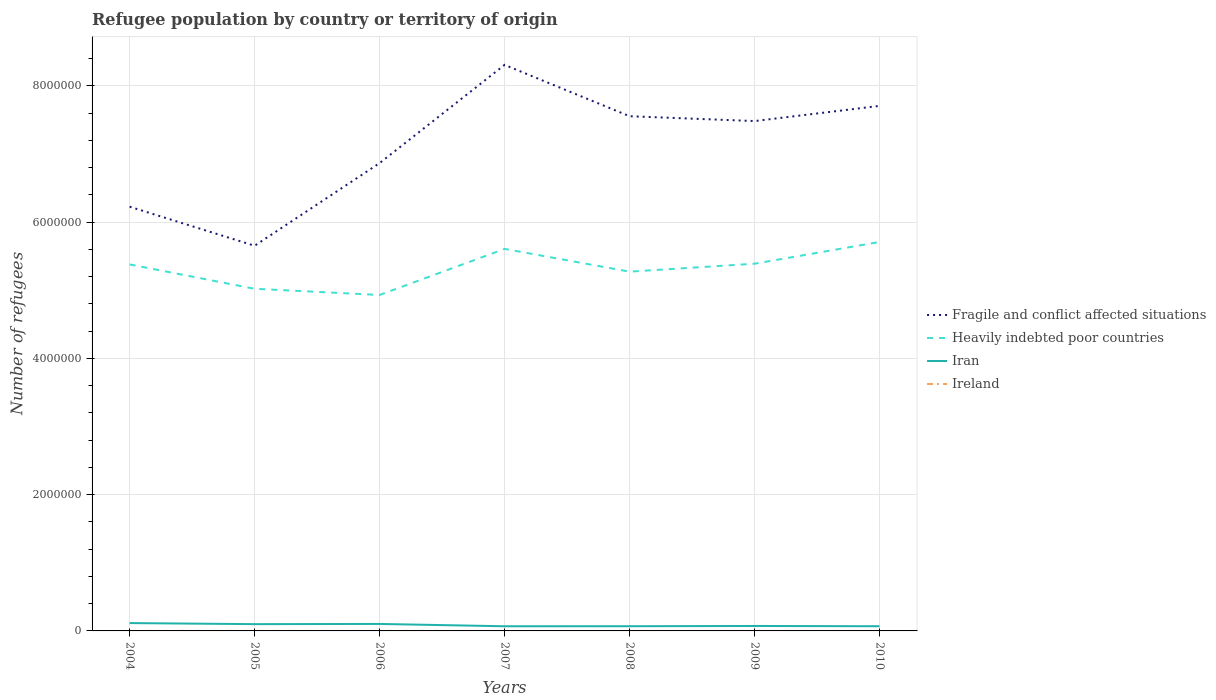Is the number of lines equal to the number of legend labels?
Make the answer very short. Yes. Across all years, what is the maximum number of refugees in Fragile and conflict affected situations?
Keep it short and to the point. 5.65e+06. What is the total number of refugees in Ireland in the graph?
Offer a very short reply. -1. What is the difference between the highest and the second highest number of refugees in Iran?
Your response must be concise. 4.68e+04. Is the number of refugees in Fragile and conflict affected situations strictly greater than the number of refugees in Heavily indebted poor countries over the years?
Provide a succinct answer. No. How many lines are there?
Ensure brevity in your answer.  4. How many years are there in the graph?
Give a very brief answer. 7. Does the graph contain grids?
Your answer should be compact. Yes. Where does the legend appear in the graph?
Provide a succinct answer. Center right. How are the legend labels stacked?
Your answer should be very brief. Vertical. What is the title of the graph?
Make the answer very short. Refugee population by country or territory of origin. What is the label or title of the Y-axis?
Offer a terse response. Number of refugees. What is the Number of refugees of Fragile and conflict affected situations in 2004?
Your answer should be very brief. 6.23e+06. What is the Number of refugees in Heavily indebted poor countries in 2004?
Provide a succinct answer. 5.38e+06. What is the Number of refugees of Iran in 2004?
Offer a terse response. 1.15e+05. What is the Number of refugees in Ireland in 2004?
Offer a terse response. 3. What is the Number of refugees in Fragile and conflict affected situations in 2005?
Make the answer very short. 5.65e+06. What is the Number of refugees of Heavily indebted poor countries in 2005?
Keep it short and to the point. 5.02e+06. What is the Number of refugees in Iran in 2005?
Provide a short and direct response. 9.94e+04. What is the Number of refugees of Ireland in 2005?
Provide a short and direct response. 21. What is the Number of refugees in Fragile and conflict affected situations in 2006?
Ensure brevity in your answer.  6.87e+06. What is the Number of refugees of Heavily indebted poor countries in 2006?
Offer a terse response. 4.93e+06. What is the Number of refugees in Iran in 2006?
Provide a short and direct response. 1.02e+05. What is the Number of refugees of Fragile and conflict affected situations in 2007?
Make the answer very short. 8.31e+06. What is the Number of refugees in Heavily indebted poor countries in 2007?
Offer a terse response. 5.61e+06. What is the Number of refugees in Iran in 2007?
Give a very brief answer. 6.84e+04. What is the Number of refugees in Fragile and conflict affected situations in 2008?
Offer a very short reply. 7.56e+06. What is the Number of refugees in Heavily indebted poor countries in 2008?
Your answer should be very brief. 5.27e+06. What is the Number of refugees in Iran in 2008?
Offer a terse response. 6.91e+04. What is the Number of refugees of Ireland in 2008?
Your answer should be compact. 7. What is the Number of refugees of Fragile and conflict affected situations in 2009?
Your answer should be very brief. 7.48e+06. What is the Number of refugees of Heavily indebted poor countries in 2009?
Provide a succinct answer. 5.39e+06. What is the Number of refugees of Iran in 2009?
Your response must be concise. 7.28e+04. What is the Number of refugees in Ireland in 2009?
Give a very brief answer. 7. What is the Number of refugees of Fragile and conflict affected situations in 2010?
Your answer should be very brief. 7.71e+06. What is the Number of refugees in Heavily indebted poor countries in 2010?
Your answer should be very brief. 5.71e+06. What is the Number of refugees of Iran in 2010?
Offer a terse response. 6.88e+04. What is the Number of refugees in Ireland in 2010?
Offer a terse response. 8. Across all years, what is the maximum Number of refugees in Fragile and conflict affected situations?
Your answer should be compact. 8.31e+06. Across all years, what is the maximum Number of refugees of Heavily indebted poor countries?
Offer a terse response. 5.71e+06. Across all years, what is the maximum Number of refugees of Iran?
Offer a very short reply. 1.15e+05. Across all years, what is the maximum Number of refugees of Ireland?
Provide a short and direct response. 21. Across all years, what is the minimum Number of refugees of Fragile and conflict affected situations?
Provide a short and direct response. 5.65e+06. Across all years, what is the minimum Number of refugees in Heavily indebted poor countries?
Your answer should be compact. 4.93e+06. Across all years, what is the minimum Number of refugees of Iran?
Keep it short and to the point. 6.84e+04. What is the total Number of refugees of Fragile and conflict affected situations in the graph?
Give a very brief answer. 4.98e+07. What is the total Number of refugees in Heavily indebted poor countries in the graph?
Provide a short and direct response. 3.73e+07. What is the total Number of refugees in Iran in the graph?
Ensure brevity in your answer.  5.96e+05. What is the difference between the Number of refugees of Fragile and conflict affected situations in 2004 and that in 2005?
Ensure brevity in your answer.  5.73e+05. What is the difference between the Number of refugees of Heavily indebted poor countries in 2004 and that in 2005?
Your answer should be very brief. 3.57e+05. What is the difference between the Number of refugees of Iran in 2004 and that in 2005?
Your answer should be very brief. 1.57e+04. What is the difference between the Number of refugees in Fragile and conflict affected situations in 2004 and that in 2006?
Give a very brief answer. -6.40e+05. What is the difference between the Number of refugees in Heavily indebted poor countries in 2004 and that in 2006?
Keep it short and to the point. 4.48e+05. What is the difference between the Number of refugees in Iran in 2004 and that in 2006?
Give a very brief answer. 1.27e+04. What is the difference between the Number of refugees in Fragile and conflict affected situations in 2004 and that in 2007?
Give a very brief answer. -2.08e+06. What is the difference between the Number of refugees in Heavily indebted poor countries in 2004 and that in 2007?
Make the answer very short. -2.28e+05. What is the difference between the Number of refugees in Iran in 2004 and that in 2007?
Your answer should be compact. 4.68e+04. What is the difference between the Number of refugees of Fragile and conflict affected situations in 2004 and that in 2008?
Your answer should be very brief. -1.33e+06. What is the difference between the Number of refugees in Heavily indebted poor countries in 2004 and that in 2008?
Keep it short and to the point. 1.06e+05. What is the difference between the Number of refugees in Iran in 2004 and that in 2008?
Your answer should be compact. 4.61e+04. What is the difference between the Number of refugees of Ireland in 2004 and that in 2008?
Offer a terse response. -4. What is the difference between the Number of refugees of Fragile and conflict affected situations in 2004 and that in 2009?
Keep it short and to the point. -1.26e+06. What is the difference between the Number of refugees of Heavily indebted poor countries in 2004 and that in 2009?
Provide a short and direct response. -1.07e+04. What is the difference between the Number of refugees of Iran in 2004 and that in 2009?
Your answer should be very brief. 4.24e+04. What is the difference between the Number of refugees in Fragile and conflict affected situations in 2004 and that in 2010?
Offer a very short reply. -1.48e+06. What is the difference between the Number of refugees of Heavily indebted poor countries in 2004 and that in 2010?
Your answer should be compact. -3.30e+05. What is the difference between the Number of refugees in Iran in 2004 and that in 2010?
Your answer should be very brief. 4.64e+04. What is the difference between the Number of refugees of Ireland in 2004 and that in 2010?
Offer a very short reply. -5. What is the difference between the Number of refugees of Fragile and conflict affected situations in 2005 and that in 2006?
Offer a very short reply. -1.21e+06. What is the difference between the Number of refugees of Heavily indebted poor countries in 2005 and that in 2006?
Your response must be concise. 9.11e+04. What is the difference between the Number of refugees in Iran in 2005 and that in 2006?
Make the answer very short. -3055. What is the difference between the Number of refugees of Fragile and conflict affected situations in 2005 and that in 2007?
Give a very brief answer. -2.66e+06. What is the difference between the Number of refugees of Heavily indebted poor countries in 2005 and that in 2007?
Your answer should be very brief. -5.85e+05. What is the difference between the Number of refugees of Iran in 2005 and that in 2007?
Offer a very short reply. 3.10e+04. What is the difference between the Number of refugees of Fragile and conflict affected situations in 2005 and that in 2008?
Offer a terse response. -1.90e+06. What is the difference between the Number of refugees of Heavily indebted poor countries in 2005 and that in 2008?
Keep it short and to the point. -2.51e+05. What is the difference between the Number of refugees in Iran in 2005 and that in 2008?
Offer a very short reply. 3.04e+04. What is the difference between the Number of refugees of Fragile and conflict affected situations in 2005 and that in 2009?
Your answer should be compact. -1.83e+06. What is the difference between the Number of refugees of Heavily indebted poor countries in 2005 and that in 2009?
Give a very brief answer. -3.68e+05. What is the difference between the Number of refugees in Iran in 2005 and that in 2009?
Give a very brief answer. 2.67e+04. What is the difference between the Number of refugees of Ireland in 2005 and that in 2009?
Your answer should be very brief. 14. What is the difference between the Number of refugees in Fragile and conflict affected situations in 2005 and that in 2010?
Your answer should be compact. -2.05e+06. What is the difference between the Number of refugees in Heavily indebted poor countries in 2005 and that in 2010?
Ensure brevity in your answer.  -6.87e+05. What is the difference between the Number of refugees in Iran in 2005 and that in 2010?
Keep it short and to the point. 3.06e+04. What is the difference between the Number of refugees of Fragile and conflict affected situations in 2006 and that in 2007?
Make the answer very short. -1.44e+06. What is the difference between the Number of refugees of Heavily indebted poor countries in 2006 and that in 2007?
Provide a short and direct response. -6.76e+05. What is the difference between the Number of refugees of Iran in 2006 and that in 2007?
Offer a very short reply. 3.41e+04. What is the difference between the Number of refugees in Fragile and conflict affected situations in 2006 and that in 2008?
Offer a terse response. -6.88e+05. What is the difference between the Number of refugees in Heavily indebted poor countries in 2006 and that in 2008?
Provide a short and direct response. -3.42e+05. What is the difference between the Number of refugees of Iran in 2006 and that in 2008?
Your response must be concise. 3.34e+04. What is the difference between the Number of refugees of Ireland in 2006 and that in 2008?
Your answer should be compact. -3. What is the difference between the Number of refugees of Fragile and conflict affected situations in 2006 and that in 2009?
Ensure brevity in your answer.  -6.17e+05. What is the difference between the Number of refugees in Heavily indebted poor countries in 2006 and that in 2009?
Provide a short and direct response. -4.59e+05. What is the difference between the Number of refugees in Iran in 2006 and that in 2009?
Offer a very short reply. 2.97e+04. What is the difference between the Number of refugees in Fragile and conflict affected situations in 2006 and that in 2010?
Your answer should be very brief. -8.40e+05. What is the difference between the Number of refugees of Heavily indebted poor countries in 2006 and that in 2010?
Keep it short and to the point. -7.78e+05. What is the difference between the Number of refugees of Iran in 2006 and that in 2010?
Make the answer very short. 3.37e+04. What is the difference between the Number of refugees of Fragile and conflict affected situations in 2007 and that in 2008?
Offer a very short reply. 7.54e+05. What is the difference between the Number of refugees of Heavily indebted poor countries in 2007 and that in 2008?
Give a very brief answer. 3.34e+05. What is the difference between the Number of refugees in Iran in 2007 and that in 2008?
Give a very brief answer. -664. What is the difference between the Number of refugees of Ireland in 2007 and that in 2008?
Ensure brevity in your answer.  3. What is the difference between the Number of refugees of Fragile and conflict affected situations in 2007 and that in 2009?
Your answer should be very brief. 8.25e+05. What is the difference between the Number of refugees of Heavily indebted poor countries in 2007 and that in 2009?
Offer a very short reply. 2.17e+05. What is the difference between the Number of refugees in Iran in 2007 and that in 2009?
Provide a succinct answer. -4377. What is the difference between the Number of refugees of Ireland in 2007 and that in 2009?
Your response must be concise. 3. What is the difference between the Number of refugees in Fragile and conflict affected situations in 2007 and that in 2010?
Provide a short and direct response. 6.02e+05. What is the difference between the Number of refugees of Heavily indebted poor countries in 2007 and that in 2010?
Provide a succinct answer. -1.02e+05. What is the difference between the Number of refugees in Iran in 2007 and that in 2010?
Your response must be concise. -394. What is the difference between the Number of refugees of Ireland in 2007 and that in 2010?
Provide a succinct answer. 2. What is the difference between the Number of refugees of Fragile and conflict affected situations in 2008 and that in 2009?
Offer a very short reply. 7.10e+04. What is the difference between the Number of refugees in Heavily indebted poor countries in 2008 and that in 2009?
Your answer should be compact. -1.17e+05. What is the difference between the Number of refugees of Iran in 2008 and that in 2009?
Your answer should be compact. -3713. What is the difference between the Number of refugees in Ireland in 2008 and that in 2009?
Offer a very short reply. 0. What is the difference between the Number of refugees of Fragile and conflict affected situations in 2008 and that in 2010?
Keep it short and to the point. -1.52e+05. What is the difference between the Number of refugees of Heavily indebted poor countries in 2008 and that in 2010?
Keep it short and to the point. -4.36e+05. What is the difference between the Number of refugees of Iran in 2008 and that in 2010?
Offer a terse response. 270. What is the difference between the Number of refugees of Fragile and conflict affected situations in 2009 and that in 2010?
Provide a succinct answer. -2.23e+05. What is the difference between the Number of refugees of Heavily indebted poor countries in 2009 and that in 2010?
Keep it short and to the point. -3.19e+05. What is the difference between the Number of refugees in Iran in 2009 and that in 2010?
Offer a terse response. 3983. What is the difference between the Number of refugees of Ireland in 2009 and that in 2010?
Offer a very short reply. -1. What is the difference between the Number of refugees of Fragile and conflict affected situations in 2004 and the Number of refugees of Heavily indebted poor countries in 2005?
Offer a very short reply. 1.20e+06. What is the difference between the Number of refugees of Fragile and conflict affected situations in 2004 and the Number of refugees of Iran in 2005?
Ensure brevity in your answer.  6.13e+06. What is the difference between the Number of refugees in Fragile and conflict affected situations in 2004 and the Number of refugees in Ireland in 2005?
Keep it short and to the point. 6.23e+06. What is the difference between the Number of refugees in Heavily indebted poor countries in 2004 and the Number of refugees in Iran in 2005?
Your answer should be very brief. 5.28e+06. What is the difference between the Number of refugees in Heavily indebted poor countries in 2004 and the Number of refugees in Ireland in 2005?
Offer a terse response. 5.38e+06. What is the difference between the Number of refugees of Iran in 2004 and the Number of refugees of Ireland in 2005?
Your answer should be very brief. 1.15e+05. What is the difference between the Number of refugees in Fragile and conflict affected situations in 2004 and the Number of refugees in Heavily indebted poor countries in 2006?
Make the answer very short. 1.30e+06. What is the difference between the Number of refugees in Fragile and conflict affected situations in 2004 and the Number of refugees in Iran in 2006?
Offer a very short reply. 6.12e+06. What is the difference between the Number of refugees of Fragile and conflict affected situations in 2004 and the Number of refugees of Ireland in 2006?
Provide a short and direct response. 6.23e+06. What is the difference between the Number of refugees in Heavily indebted poor countries in 2004 and the Number of refugees in Iran in 2006?
Offer a very short reply. 5.28e+06. What is the difference between the Number of refugees in Heavily indebted poor countries in 2004 and the Number of refugees in Ireland in 2006?
Ensure brevity in your answer.  5.38e+06. What is the difference between the Number of refugees of Iran in 2004 and the Number of refugees of Ireland in 2006?
Keep it short and to the point. 1.15e+05. What is the difference between the Number of refugees in Fragile and conflict affected situations in 2004 and the Number of refugees in Heavily indebted poor countries in 2007?
Provide a short and direct response. 6.19e+05. What is the difference between the Number of refugees of Fragile and conflict affected situations in 2004 and the Number of refugees of Iran in 2007?
Make the answer very short. 6.16e+06. What is the difference between the Number of refugees in Fragile and conflict affected situations in 2004 and the Number of refugees in Ireland in 2007?
Provide a short and direct response. 6.23e+06. What is the difference between the Number of refugees in Heavily indebted poor countries in 2004 and the Number of refugees in Iran in 2007?
Provide a short and direct response. 5.31e+06. What is the difference between the Number of refugees of Heavily indebted poor countries in 2004 and the Number of refugees of Ireland in 2007?
Provide a short and direct response. 5.38e+06. What is the difference between the Number of refugees in Iran in 2004 and the Number of refugees in Ireland in 2007?
Make the answer very short. 1.15e+05. What is the difference between the Number of refugees of Fragile and conflict affected situations in 2004 and the Number of refugees of Heavily indebted poor countries in 2008?
Keep it short and to the point. 9.53e+05. What is the difference between the Number of refugees of Fragile and conflict affected situations in 2004 and the Number of refugees of Iran in 2008?
Offer a very short reply. 6.16e+06. What is the difference between the Number of refugees in Fragile and conflict affected situations in 2004 and the Number of refugees in Ireland in 2008?
Keep it short and to the point. 6.23e+06. What is the difference between the Number of refugees in Heavily indebted poor countries in 2004 and the Number of refugees in Iran in 2008?
Your response must be concise. 5.31e+06. What is the difference between the Number of refugees in Heavily indebted poor countries in 2004 and the Number of refugees in Ireland in 2008?
Keep it short and to the point. 5.38e+06. What is the difference between the Number of refugees in Iran in 2004 and the Number of refugees in Ireland in 2008?
Offer a terse response. 1.15e+05. What is the difference between the Number of refugees in Fragile and conflict affected situations in 2004 and the Number of refugees in Heavily indebted poor countries in 2009?
Make the answer very short. 8.37e+05. What is the difference between the Number of refugees in Fragile and conflict affected situations in 2004 and the Number of refugees in Iran in 2009?
Keep it short and to the point. 6.15e+06. What is the difference between the Number of refugees of Fragile and conflict affected situations in 2004 and the Number of refugees of Ireland in 2009?
Offer a very short reply. 6.23e+06. What is the difference between the Number of refugees of Heavily indebted poor countries in 2004 and the Number of refugees of Iran in 2009?
Give a very brief answer. 5.31e+06. What is the difference between the Number of refugees in Heavily indebted poor countries in 2004 and the Number of refugees in Ireland in 2009?
Make the answer very short. 5.38e+06. What is the difference between the Number of refugees of Iran in 2004 and the Number of refugees of Ireland in 2009?
Offer a terse response. 1.15e+05. What is the difference between the Number of refugees in Fragile and conflict affected situations in 2004 and the Number of refugees in Heavily indebted poor countries in 2010?
Provide a short and direct response. 5.18e+05. What is the difference between the Number of refugees of Fragile and conflict affected situations in 2004 and the Number of refugees of Iran in 2010?
Give a very brief answer. 6.16e+06. What is the difference between the Number of refugees in Fragile and conflict affected situations in 2004 and the Number of refugees in Ireland in 2010?
Keep it short and to the point. 6.23e+06. What is the difference between the Number of refugees in Heavily indebted poor countries in 2004 and the Number of refugees in Iran in 2010?
Offer a terse response. 5.31e+06. What is the difference between the Number of refugees in Heavily indebted poor countries in 2004 and the Number of refugees in Ireland in 2010?
Provide a succinct answer. 5.38e+06. What is the difference between the Number of refugees of Iran in 2004 and the Number of refugees of Ireland in 2010?
Provide a short and direct response. 1.15e+05. What is the difference between the Number of refugees of Fragile and conflict affected situations in 2005 and the Number of refugees of Heavily indebted poor countries in 2006?
Ensure brevity in your answer.  7.23e+05. What is the difference between the Number of refugees of Fragile and conflict affected situations in 2005 and the Number of refugees of Iran in 2006?
Provide a short and direct response. 5.55e+06. What is the difference between the Number of refugees of Fragile and conflict affected situations in 2005 and the Number of refugees of Ireland in 2006?
Provide a short and direct response. 5.65e+06. What is the difference between the Number of refugees of Heavily indebted poor countries in 2005 and the Number of refugees of Iran in 2006?
Provide a short and direct response. 4.92e+06. What is the difference between the Number of refugees of Heavily indebted poor countries in 2005 and the Number of refugees of Ireland in 2006?
Offer a terse response. 5.02e+06. What is the difference between the Number of refugees in Iran in 2005 and the Number of refugees in Ireland in 2006?
Keep it short and to the point. 9.94e+04. What is the difference between the Number of refugees in Fragile and conflict affected situations in 2005 and the Number of refugees in Heavily indebted poor countries in 2007?
Provide a succinct answer. 4.64e+04. What is the difference between the Number of refugees of Fragile and conflict affected situations in 2005 and the Number of refugees of Iran in 2007?
Your answer should be very brief. 5.59e+06. What is the difference between the Number of refugees in Fragile and conflict affected situations in 2005 and the Number of refugees in Ireland in 2007?
Keep it short and to the point. 5.65e+06. What is the difference between the Number of refugees in Heavily indebted poor countries in 2005 and the Number of refugees in Iran in 2007?
Make the answer very short. 4.95e+06. What is the difference between the Number of refugees in Heavily indebted poor countries in 2005 and the Number of refugees in Ireland in 2007?
Provide a succinct answer. 5.02e+06. What is the difference between the Number of refugees of Iran in 2005 and the Number of refugees of Ireland in 2007?
Offer a very short reply. 9.94e+04. What is the difference between the Number of refugees of Fragile and conflict affected situations in 2005 and the Number of refugees of Heavily indebted poor countries in 2008?
Keep it short and to the point. 3.80e+05. What is the difference between the Number of refugees of Fragile and conflict affected situations in 2005 and the Number of refugees of Iran in 2008?
Provide a short and direct response. 5.59e+06. What is the difference between the Number of refugees of Fragile and conflict affected situations in 2005 and the Number of refugees of Ireland in 2008?
Your answer should be very brief. 5.65e+06. What is the difference between the Number of refugees in Heavily indebted poor countries in 2005 and the Number of refugees in Iran in 2008?
Offer a terse response. 4.95e+06. What is the difference between the Number of refugees of Heavily indebted poor countries in 2005 and the Number of refugees of Ireland in 2008?
Provide a succinct answer. 5.02e+06. What is the difference between the Number of refugees in Iran in 2005 and the Number of refugees in Ireland in 2008?
Offer a very short reply. 9.94e+04. What is the difference between the Number of refugees in Fragile and conflict affected situations in 2005 and the Number of refugees in Heavily indebted poor countries in 2009?
Keep it short and to the point. 2.64e+05. What is the difference between the Number of refugees in Fragile and conflict affected situations in 2005 and the Number of refugees in Iran in 2009?
Offer a terse response. 5.58e+06. What is the difference between the Number of refugees of Fragile and conflict affected situations in 2005 and the Number of refugees of Ireland in 2009?
Your answer should be compact. 5.65e+06. What is the difference between the Number of refugees in Heavily indebted poor countries in 2005 and the Number of refugees in Iran in 2009?
Offer a terse response. 4.95e+06. What is the difference between the Number of refugees of Heavily indebted poor countries in 2005 and the Number of refugees of Ireland in 2009?
Provide a succinct answer. 5.02e+06. What is the difference between the Number of refugees in Iran in 2005 and the Number of refugees in Ireland in 2009?
Make the answer very short. 9.94e+04. What is the difference between the Number of refugees in Fragile and conflict affected situations in 2005 and the Number of refugees in Heavily indebted poor countries in 2010?
Your answer should be very brief. -5.55e+04. What is the difference between the Number of refugees in Fragile and conflict affected situations in 2005 and the Number of refugees in Iran in 2010?
Provide a short and direct response. 5.59e+06. What is the difference between the Number of refugees in Fragile and conflict affected situations in 2005 and the Number of refugees in Ireland in 2010?
Offer a very short reply. 5.65e+06. What is the difference between the Number of refugees of Heavily indebted poor countries in 2005 and the Number of refugees of Iran in 2010?
Make the answer very short. 4.95e+06. What is the difference between the Number of refugees in Heavily indebted poor countries in 2005 and the Number of refugees in Ireland in 2010?
Offer a very short reply. 5.02e+06. What is the difference between the Number of refugees in Iran in 2005 and the Number of refugees in Ireland in 2010?
Offer a terse response. 9.94e+04. What is the difference between the Number of refugees of Fragile and conflict affected situations in 2006 and the Number of refugees of Heavily indebted poor countries in 2007?
Your answer should be very brief. 1.26e+06. What is the difference between the Number of refugees of Fragile and conflict affected situations in 2006 and the Number of refugees of Iran in 2007?
Give a very brief answer. 6.80e+06. What is the difference between the Number of refugees of Fragile and conflict affected situations in 2006 and the Number of refugees of Ireland in 2007?
Give a very brief answer. 6.87e+06. What is the difference between the Number of refugees in Heavily indebted poor countries in 2006 and the Number of refugees in Iran in 2007?
Offer a very short reply. 4.86e+06. What is the difference between the Number of refugees of Heavily indebted poor countries in 2006 and the Number of refugees of Ireland in 2007?
Offer a very short reply. 4.93e+06. What is the difference between the Number of refugees of Iran in 2006 and the Number of refugees of Ireland in 2007?
Provide a short and direct response. 1.02e+05. What is the difference between the Number of refugees in Fragile and conflict affected situations in 2006 and the Number of refugees in Heavily indebted poor countries in 2008?
Your answer should be very brief. 1.59e+06. What is the difference between the Number of refugees of Fragile and conflict affected situations in 2006 and the Number of refugees of Iran in 2008?
Your answer should be very brief. 6.80e+06. What is the difference between the Number of refugees in Fragile and conflict affected situations in 2006 and the Number of refugees in Ireland in 2008?
Provide a short and direct response. 6.87e+06. What is the difference between the Number of refugees of Heavily indebted poor countries in 2006 and the Number of refugees of Iran in 2008?
Provide a short and direct response. 4.86e+06. What is the difference between the Number of refugees of Heavily indebted poor countries in 2006 and the Number of refugees of Ireland in 2008?
Make the answer very short. 4.93e+06. What is the difference between the Number of refugees of Iran in 2006 and the Number of refugees of Ireland in 2008?
Your response must be concise. 1.02e+05. What is the difference between the Number of refugees in Fragile and conflict affected situations in 2006 and the Number of refugees in Heavily indebted poor countries in 2009?
Your response must be concise. 1.48e+06. What is the difference between the Number of refugees of Fragile and conflict affected situations in 2006 and the Number of refugees of Iran in 2009?
Your response must be concise. 6.79e+06. What is the difference between the Number of refugees in Fragile and conflict affected situations in 2006 and the Number of refugees in Ireland in 2009?
Your response must be concise. 6.87e+06. What is the difference between the Number of refugees of Heavily indebted poor countries in 2006 and the Number of refugees of Iran in 2009?
Give a very brief answer. 4.86e+06. What is the difference between the Number of refugees of Heavily indebted poor countries in 2006 and the Number of refugees of Ireland in 2009?
Provide a short and direct response. 4.93e+06. What is the difference between the Number of refugees in Iran in 2006 and the Number of refugees in Ireland in 2009?
Make the answer very short. 1.02e+05. What is the difference between the Number of refugees in Fragile and conflict affected situations in 2006 and the Number of refugees in Heavily indebted poor countries in 2010?
Provide a succinct answer. 1.16e+06. What is the difference between the Number of refugees of Fragile and conflict affected situations in 2006 and the Number of refugees of Iran in 2010?
Give a very brief answer. 6.80e+06. What is the difference between the Number of refugees of Fragile and conflict affected situations in 2006 and the Number of refugees of Ireland in 2010?
Your response must be concise. 6.87e+06. What is the difference between the Number of refugees of Heavily indebted poor countries in 2006 and the Number of refugees of Iran in 2010?
Your answer should be very brief. 4.86e+06. What is the difference between the Number of refugees of Heavily indebted poor countries in 2006 and the Number of refugees of Ireland in 2010?
Offer a terse response. 4.93e+06. What is the difference between the Number of refugees in Iran in 2006 and the Number of refugees in Ireland in 2010?
Your response must be concise. 1.02e+05. What is the difference between the Number of refugees of Fragile and conflict affected situations in 2007 and the Number of refugees of Heavily indebted poor countries in 2008?
Your answer should be compact. 3.04e+06. What is the difference between the Number of refugees of Fragile and conflict affected situations in 2007 and the Number of refugees of Iran in 2008?
Give a very brief answer. 8.24e+06. What is the difference between the Number of refugees of Fragile and conflict affected situations in 2007 and the Number of refugees of Ireland in 2008?
Your answer should be compact. 8.31e+06. What is the difference between the Number of refugees in Heavily indebted poor countries in 2007 and the Number of refugees in Iran in 2008?
Your answer should be very brief. 5.54e+06. What is the difference between the Number of refugees in Heavily indebted poor countries in 2007 and the Number of refugees in Ireland in 2008?
Offer a very short reply. 5.61e+06. What is the difference between the Number of refugees in Iran in 2007 and the Number of refugees in Ireland in 2008?
Keep it short and to the point. 6.84e+04. What is the difference between the Number of refugees of Fragile and conflict affected situations in 2007 and the Number of refugees of Heavily indebted poor countries in 2009?
Offer a very short reply. 2.92e+06. What is the difference between the Number of refugees of Fragile and conflict affected situations in 2007 and the Number of refugees of Iran in 2009?
Provide a short and direct response. 8.24e+06. What is the difference between the Number of refugees of Fragile and conflict affected situations in 2007 and the Number of refugees of Ireland in 2009?
Ensure brevity in your answer.  8.31e+06. What is the difference between the Number of refugees in Heavily indebted poor countries in 2007 and the Number of refugees in Iran in 2009?
Make the answer very short. 5.54e+06. What is the difference between the Number of refugees of Heavily indebted poor countries in 2007 and the Number of refugees of Ireland in 2009?
Offer a terse response. 5.61e+06. What is the difference between the Number of refugees in Iran in 2007 and the Number of refugees in Ireland in 2009?
Provide a succinct answer. 6.84e+04. What is the difference between the Number of refugees of Fragile and conflict affected situations in 2007 and the Number of refugees of Heavily indebted poor countries in 2010?
Give a very brief answer. 2.60e+06. What is the difference between the Number of refugees in Fragile and conflict affected situations in 2007 and the Number of refugees in Iran in 2010?
Ensure brevity in your answer.  8.24e+06. What is the difference between the Number of refugees of Fragile and conflict affected situations in 2007 and the Number of refugees of Ireland in 2010?
Your response must be concise. 8.31e+06. What is the difference between the Number of refugees of Heavily indebted poor countries in 2007 and the Number of refugees of Iran in 2010?
Offer a very short reply. 5.54e+06. What is the difference between the Number of refugees in Heavily indebted poor countries in 2007 and the Number of refugees in Ireland in 2010?
Your answer should be very brief. 5.61e+06. What is the difference between the Number of refugees of Iran in 2007 and the Number of refugees of Ireland in 2010?
Make the answer very short. 6.84e+04. What is the difference between the Number of refugees in Fragile and conflict affected situations in 2008 and the Number of refugees in Heavily indebted poor countries in 2009?
Provide a short and direct response. 2.16e+06. What is the difference between the Number of refugees of Fragile and conflict affected situations in 2008 and the Number of refugees of Iran in 2009?
Your response must be concise. 7.48e+06. What is the difference between the Number of refugees in Fragile and conflict affected situations in 2008 and the Number of refugees in Ireland in 2009?
Offer a very short reply. 7.56e+06. What is the difference between the Number of refugees of Heavily indebted poor countries in 2008 and the Number of refugees of Iran in 2009?
Offer a terse response. 5.20e+06. What is the difference between the Number of refugees in Heavily indebted poor countries in 2008 and the Number of refugees in Ireland in 2009?
Keep it short and to the point. 5.27e+06. What is the difference between the Number of refugees of Iran in 2008 and the Number of refugees of Ireland in 2009?
Offer a very short reply. 6.91e+04. What is the difference between the Number of refugees of Fragile and conflict affected situations in 2008 and the Number of refugees of Heavily indebted poor countries in 2010?
Keep it short and to the point. 1.85e+06. What is the difference between the Number of refugees of Fragile and conflict affected situations in 2008 and the Number of refugees of Iran in 2010?
Give a very brief answer. 7.49e+06. What is the difference between the Number of refugees in Fragile and conflict affected situations in 2008 and the Number of refugees in Ireland in 2010?
Give a very brief answer. 7.56e+06. What is the difference between the Number of refugees of Heavily indebted poor countries in 2008 and the Number of refugees of Iran in 2010?
Provide a short and direct response. 5.21e+06. What is the difference between the Number of refugees in Heavily indebted poor countries in 2008 and the Number of refugees in Ireland in 2010?
Your answer should be compact. 5.27e+06. What is the difference between the Number of refugees of Iran in 2008 and the Number of refugees of Ireland in 2010?
Make the answer very short. 6.91e+04. What is the difference between the Number of refugees of Fragile and conflict affected situations in 2009 and the Number of refugees of Heavily indebted poor countries in 2010?
Provide a short and direct response. 1.77e+06. What is the difference between the Number of refugees in Fragile and conflict affected situations in 2009 and the Number of refugees in Iran in 2010?
Ensure brevity in your answer.  7.42e+06. What is the difference between the Number of refugees of Fragile and conflict affected situations in 2009 and the Number of refugees of Ireland in 2010?
Provide a short and direct response. 7.48e+06. What is the difference between the Number of refugees in Heavily indebted poor countries in 2009 and the Number of refugees in Iran in 2010?
Ensure brevity in your answer.  5.32e+06. What is the difference between the Number of refugees of Heavily indebted poor countries in 2009 and the Number of refugees of Ireland in 2010?
Provide a succinct answer. 5.39e+06. What is the difference between the Number of refugees of Iran in 2009 and the Number of refugees of Ireland in 2010?
Provide a succinct answer. 7.28e+04. What is the average Number of refugees in Fragile and conflict affected situations per year?
Your response must be concise. 7.12e+06. What is the average Number of refugees of Heavily indebted poor countries per year?
Offer a very short reply. 5.33e+06. What is the average Number of refugees in Iran per year?
Offer a very short reply. 8.52e+04. What is the average Number of refugees in Ireland per year?
Your answer should be compact. 8.57. In the year 2004, what is the difference between the Number of refugees of Fragile and conflict affected situations and Number of refugees of Heavily indebted poor countries?
Give a very brief answer. 8.47e+05. In the year 2004, what is the difference between the Number of refugees of Fragile and conflict affected situations and Number of refugees of Iran?
Your answer should be very brief. 6.11e+06. In the year 2004, what is the difference between the Number of refugees of Fragile and conflict affected situations and Number of refugees of Ireland?
Your answer should be compact. 6.23e+06. In the year 2004, what is the difference between the Number of refugees in Heavily indebted poor countries and Number of refugees in Iran?
Offer a very short reply. 5.26e+06. In the year 2004, what is the difference between the Number of refugees in Heavily indebted poor countries and Number of refugees in Ireland?
Give a very brief answer. 5.38e+06. In the year 2004, what is the difference between the Number of refugees of Iran and Number of refugees of Ireland?
Provide a short and direct response. 1.15e+05. In the year 2005, what is the difference between the Number of refugees of Fragile and conflict affected situations and Number of refugees of Heavily indebted poor countries?
Give a very brief answer. 6.32e+05. In the year 2005, what is the difference between the Number of refugees in Fragile and conflict affected situations and Number of refugees in Iran?
Provide a short and direct response. 5.55e+06. In the year 2005, what is the difference between the Number of refugees in Fragile and conflict affected situations and Number of refugees in Ireland?
Your answer should be very brief. 5.65e+06. In the year 2005, what is the difference between the Number of refugees in Heavily indebted poor countries and Number of refugees in Iran?
Give a very brief answer. 4.92e+06. In the year 2005, what is the difference between the Number of refugees in Heavily indebted poor countries and Number of refugees in Ireland?
Provide a succinct answer. 5.02e+06. In the year 2005, what is the difference between the Number of refugees of Iran and Number of refugees of Ireland?
Your answer should be very brief. 9.94e+04. In the year 2006, what is the difference between the Number of refugees in Fragile and conflict affected situations and Number of refugees in Heavily indebted poor countries?
Offer a terse response. 1.94e+06. In the year 2006, what is the difference between the Number of refugees in Fragile and conflict affected situations and Number of refugees in Iran?
Provide a succinct answer. 6.77e+06. In the year 2006, what is the difference between the Number of refugees of Fragile and conflict affected situations and Number of refugees of Ireland?
Keep it short and to the point. 6.87e+06. In the year 2006, what is the difference between the Number of refugees in Heavily indebted poor countries and Number of refugees in Iran?
Provide a short and direct response. 4.83e+06. In the year 2006, what is the difference between the Number of refugees of Heavily indebted poor countries and Number of refugees of Ireland?
Ensure brevity in your answer.  4.93e+06. In the year 2006, what is the difference between the Number of refugees of Iran and Number of refugees of Ireland?
Provide a short and direct response. 1.02e+05. In the year 2007, what is the difference between the Number of refugees in Fragile and conflict affected situations and Number of refugees in Heavily indebted poor countries?
Provide a short and direct response. 2.70e+06. In the year 2007, what is the difference between the Number of refugees of Fragile and conflict affected situations and Number of refugees of Iran?
Keep it short and to the point. 8.24e+06. In the year 2007, what is the difference between the Number of refugees in Fragile and conflict affected situations and Number of refugees in Ireland?
Offer a very short reply. 8.31e+06. In the year 2007, what is the difference between the Number of refugees in Heavily indebted poor countries and Number of refugees in Iran?
Keep it short and to the point. 5.54e+06. In the year 2007, what is the difference between the Number of refugees in Heavily indebted poor countries and Number of refugees in Ireland?
Your response must be concise. 5.61e+06. In the year 2007, what is the difference between the Number of refugees in Iran and Number of refugees in Ireland?
Keep it short and to the point. 6.84e+04. In the year 2008, what is the difference between the Number of refugees in Fragile and conflict affected situations and Number of refugees in Heavily indebted poor countries?
Provide a short and direct response. 2.28e+06. In the year 2008, what is the difference between the Number of refugees of Fragile and conflict affected situations and Number of refugees of Iran?
Offer a very short reply. 7.49e+06. In the year 2008, what is the difference between the Number of refugees in Fragile and conflict affected situations and Number of refugees in Ireland?
Give a very brief answer. 7.56e+06. In the year 2008, what is the difference between the Number of refugees in Heavily indebted poor countries and Number of refugees in Iran?
Offer a terse response. 5.20e+06. In the year 2008, what is the difference between the Number of refugees of Heavily indebted poor countries and Number of refugees of Ireland?
Offer a terse response. 5.27e+06. In the year 2008, what is the difference between the Number of refugees in Iran and Number of refugees in Ireland?
Make the answer very short. 6.91e+04. In the year 2009, what is the difference between the Number of refugees of Fragile and conflict affected situations and Number of refugees of Heavily indebted poor countries?
Make the answer very short. 2.09e+06. In the year 2009, what is the difference between the Number of refugees of Fragile and conflict affected situations and Number of refugees of Iran?
Your answer should be very brief. 7.41e+06. In the year 2009, what is the difference between the Number of refugees in Fragile and conflict affected situations and Number of refugees in Ireland?
Keep it short and to the point. 7.48e+06. In the year 2009, what is the difference between the Number of refugees of Heavily indebted poor countries and Number of refugees of Iran?
Offer a terse response. 5.32e+06. In the year 2009, what is the difference between the Number of refugees of Heavily indebted poor countries and Number of refugees of Ireland?
Provide a succinct answer. 5.39e+06. In the year 2009, what is the difference between the Number of refugees in Iran and Number of refugees in Ireland?
Your response must be concise. 7.28e+04. In the year 2010, what is the difference between the Number of refugees in Fragile and conflict affected situations and Number of refugees in Heavily indebted poor countries?
Provide a succinct answer. 2.00e+06. In the year 2010, what is the difference between the Number of refugees of Fragile and conflict affected situations and Number of refugees of Iran?
Ensure brevity in your answer.  7.64e+06. In the year 2010, what is the difference between the Number of refugees in Fragile and conflict affected situations and Number of refugees in Ireland?
Provide a succinct answer. 7.71e+06. In the year 2010, what is the difference between the Number of refugees of Heavily indebted poor countries and Number of refugees of Iran?
Your response must be concise. 5.64e+06. In the year 2010, what is the difference between the Number of refugees in Heavily indebted poor countries and Number of refugees in Ireland?
Keep it short and to the point. 5.71e+06. In the year 2010, what is the difference between the Number of refugees of Iran and Number of refugees of Ireland?
Give a very brief answer. 6.88e+04. What is the ratio of the Number of refugees in Fragile and conflict affected situations in 2004 to that in 2005?
Offer a terse response. 1.1. What is the ratio of the Number of refugees of Heavily indebted poor countries in 2004 to that in 2005?
Your response must be concise. 1.07. What is the ratio of the Number of refugees in Iran in 2004 to that in 2005?
Your answer should be very brief. 1.16. What is the ratio of the Number of refugees of Ireland in 2004 to that in 2005?
Your response must be concise. 0.14. What is the ratio of the Number of refugees in Fragile and conflict affected situations in 2004 to that in 2006?
Make the answer very short. 0.91. What is the ratio of the Number of refugees in Iran in 2004 to that in 2006?
Ensure brevity in your answer.  1.12. What is the ratio of the Number of refugees in Fragile and conflict affected situations in 2004 to that in 2007?
Make the answer very short. 0.75. What is the ratio of the Number of refugees of Heavily indebted poor countries in 2004 to that in 2007?
Your response must be concise. 0.96. What is the ratio of the Number of refugees in Iran in 2004 to that in 2007?
Ensure brevity in your answer.  1.68. What is the ratio of the Number of refugees of Fragile and conflict affected situations in 2004 to that in 2008?
Give a very brief answer. 0.82. What is the ratio of the Number of refugees of Heavily indebted poor countries in 2004 to that in 2008?
Your response must be concise. 1.02. What is the ratio of the Number of refugees of Iran in 2004 to that in 2008?
Ensure brevity in your answer.  1.67. What is the ratio of the Number of refugees of Ireland in 2004 to that in 2008?
Make the answer very short. 0.43. What is the ratio of the Number of refugees of Fragile and conflict affected situations in 2004 to that in 2009?
Offer a terse response. 0.83. What is the ratio of the Number of refugees of Heavily indebted poor countries in 2004 to that in 2009?
Keep it short and to the point. 1. What is the ratio of the Number of refugees in Iran in 2004 to that in 2009?
Keep it short and to the point. 1.58. What is the ratio of the Number of refugees of Ireland in 2004 to that in 2009?
Make the answer very short. 0.43. What is the ratio of the Number of refugees of Fragile and conflict affected situations in 2004 to that in 2010?
Offer a terse response. 0.81. What is the ratio of the Number of refugees of Heavily indebted poor countries in 2004 to that in 2010?
Ensure brevity in your answer.  0.94. What is the ratio of the Number of refugees in Iran in 2004 to that in 2010?
Make the answer very short. 1.67. What is the ratio of the Number of refugees in Fragile and conflict affected situations in 2005 to that in 2006?
Provide a succinct answer. 0.82. What is the ratio of the Number of refugees of Heavily indebted poor countries in 2005 to that in 2006?
Your answer should be compact. 1.02. What is the ratio of the Number of refugees of Iran in 2005 to that in 2006?
Offer a very short reply. 0.97. What is the ratio of the Number of refugees of Ireland in 2005 to that in 2006?
Make the answer very short. 5.25. What is the ratio of the Number of refugees in Fragile and conflict affected situations in 2005 to that in 2007?
Keep it short and to the point. 0.68. What is the ratio of the Number of refugees in Heavily indebted poor countries in 2005 to that in 2007?
Keep it short and to the point. 0.9. What is the ratio of the Number of refugees in Iran in 2005 to that in 2007?
Provide a succinct answer. 1.45. What is the ratio of the Number of refugees in Ireland in 2005 to that in 2007?
Offer a terse response. 2.1. What is the ratio of the Number of refugees in Fragile and conflict affected situations in 2005 to that in 2008?
Ensure brevity in your answer.  0.75. What is the ratio of the Number of refugees in Iran in 2005 to that in 2008?
Offer a very short reply. 1.44. What is the ratio of the Number of refugees in Ireland in 2005 to that in 2008?
Offer a very short reply. 3. What is the ratio of the Number of refugees of Fragile and conflict affected situations in 2005 to that in 2009?
Provide a short and direct response. 0.76. What is the ratio of the Number of refugees of Heavily indebted poor countries in 2005 to that in 2009?
Offer a very short reply. 0.93. What is the ratio of the Number of refugees in Iran in 2005 to that in 2009?
Provide a short and direct response. 1.37. What is the ratio of the Number of refugees of Fragile and conflict affected situations in 2005 to that in 2010?
Provide a succinct answer. 0.73. What is the ratio of the Number of refugees in Heavily indebted poor countries in 2005 to that in 2010?
Provide a short and direct response. 0.88. What is the ratio of the Number of refugees of Iran in 2005 to that in 2010?
Offer a terse response. 1.45. What is the ratio of the Number of refugees in Ireland in 2005 to that in 2010?
Your answer should be compact. 2.62. What is the ratio of the Number of refugees of Fragile and conflict affected situations in 2006 to that in 2007?
Give a very brief answer. 0.83. What is the ratio of the Number of refugees of Heavily indebted poor countries in 2006 to that in 2007?
Ensure brevity in your answer.  0.88. What is the ratio of the Number of refugees of Iran in 2006 to that in 2007?
Offer a terse response. 1.5. What is the ratio of the Number of refugees in Fragile and conflict affected situations in 2006 to that in 2008?
Your answer should be compact. 0.91. What is the ratio of the Number of refugees of Heavily indebted poor countries in 2006 to that in 2008?
Your response must be concise. 0.94. What is the ratio of the Number of refugees of Iran in 2006 to that in 2008?
Provide a short and direct response. 1.48. What is the ratio of the Number of refugees in Fragile and conflict affected situations in 2006 to that in 2009?
Provide a succinct answer. 0.92. What is the ratio of the Number of refugees in Heavily indebted poor countries in 2006 to that in 2009?
Offer a terse response. 0.91. What is the ratio of the Number of refugees of Iran in 2006 to that in 2009?
Your response must be concise. 1.41. What is the ratio of the Number of refugees in Ireland in 2006 to that in 2009?
Provide a short and direct response. 0.57. What is the ratio of the Number of refugees of Fragile and conflict affected situations in 2006 to that in 2010?
Your response must be concise. 0.89. What is the ratio of the Number of refugees in Heavily indebted poor countries in 2006 to that in 2010?
Offer a very short reply. 0.86. What is the ratio of the Number of refugees of Iran in 2006 to that in 2010?
Make the answer very short. 1.49. What is the ratio of the Number of refugees in Fragile and conflict affected situations in 2007 to that in 2008?
Your answer should be very brief. 1.1. What is the ratio of the Number of refugees in Heavily indebted poor countries in 2007 to that in 2008?
Keep it short and to the point. 1.06. What is the ratio of the Number of refugees in Iran in 2007 to that in 2008?
Provide a short and direct response. 0.99. What is the ratio of the Number of refugees in Ireland in 2007 to that in 2008?
Provide a short and direct response. 1.43. What is the ratio of the Number of refugees of Fragile and conflict affected situations in 2007 to that in 2009?
Keep it short and to the point. 1.11. What is the ratio of the Number of refugees in Heavily indebted poor countries in 2007 to that in 2009?
Your answer should be compact. 1.04. What is the ratio of the Number of refugees in Iran in 2007 to that in 2009?
Give a very brief answer. 0.94. What is the ratio of the Number of refugees in Ireland in 2007 to that in 2009?
Offer a terse response. 1.43. What is the ratio of the Number of refugees in Fragile and conflict affected situations in 2007 to that in 2010?
Make the answer very short. 1.08. What is the ratio of the Number of refugees in Heavily indebted poor countries in 2007 to that in 2010?
Your answer should be very brief. 0.98. What is the ratio of the Number of refugees in Iran in 2007 to that in 2010?
Keep it short and to the point. 0.99. What is the ratio of the Number of refugees in Ireland in 2007 to that in 2010?
Ensure brevity in your answer.  1.25. What is the ratio of the Number of refugees of Fragile and conflict affected situations in 2008 to that in 2009?
Provide a short and direct response. 1.01. What is the ratio of the Number of refugees of Heavily indebted poor countries in 2008 to that in 2009?
Provide a succinct answer. 0.98. What is the ratio of the Number of refugees of Iran in 2008 to that in 2009?
Give a very brief answer. 0.95. What is the ratio of the Number of refugees of Fragile and conflict affected situations in 2008 to that in 2010?
Your answer should be very brief. 0.98. What is the ratio of the Number of refugees of Heavily indebted poor countries in 2008 to that in 2010?
Ensure brevity in your answer.  0.92. What is the ratio of the Number of refugees in Iran in 2008 to that in 2010?
Make the answer very short. 1. What is the ratio of the Number of refugees of Fragile and conflict affected situations in 2009 to that in 2010?
Keep it short and to the point. 0.97. What is the ratio of the Number of refugees in Heavily indebted poor countries in 2009 to that in 2010?
Offer a terse response. 0.94. What is the ratio of the Number of refugees of Iran in 2009 to that in 2010?
Your answer should be compact. 1.06. What is the difference between the highest and the second highest Number of refugees of Fragile and conflict affected situations?
Your answer should be very brief. 6.02e+05. What is the difference between the highest and the second highest Number of refugees of Heavily indebted poor countries?
Give a very brief answer. 1.02e+05. What is the difference between the highest and the second highest Number of refugees of Iran?
Give a very brief answer. 1.27e+04. What is the difference between the highest and the lowest Number of refugees of Fragile and conflict affected situations?
Offer a very short reply. 2.66e+06. What is the difference between the highest and the lowest Number of refugees in Heavily indebted poor countries?
Your answer should be compact. 7.78e+05. What is the difference between the highest and the lowest Number of refugees of Iran?
Keep it short and to the point. 4.68e+04. What is the difference between the highest and the lowest Number of refugees of Ireland?
Give a very brief answer. 18. 